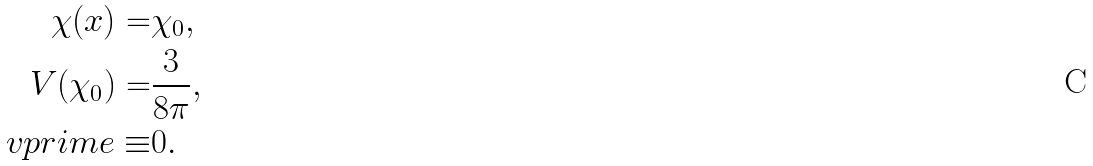<formula> <loc_0><loc_0><loc_500><loc_500>\chi ( x ) = & \chi _ { 0 } , \\ V ( \chi _ { 0 } ) = & \frac { 3 } { 8 \pi } , \\ \ v p r i m e \equiv & 0 .</formula> 